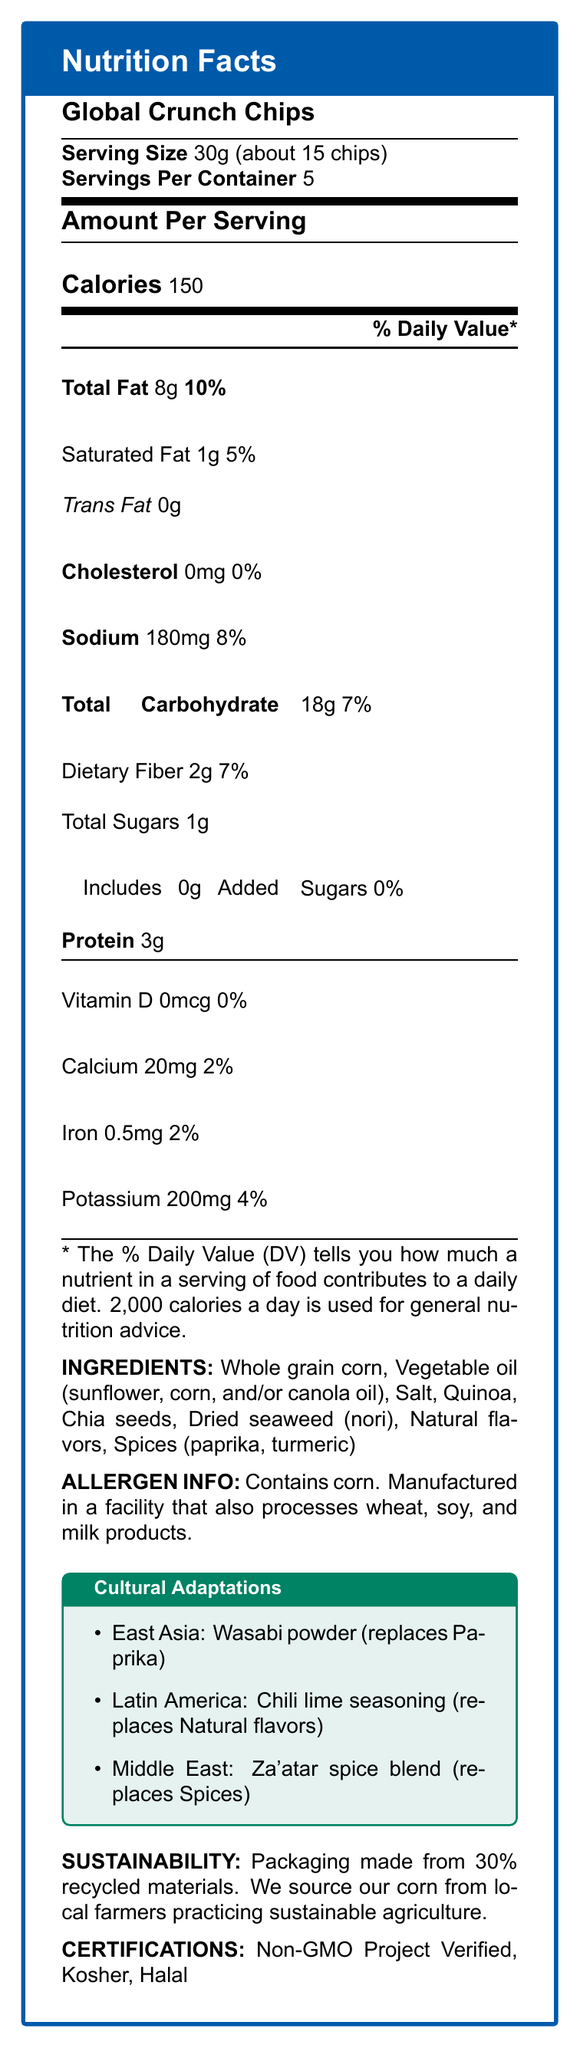what is the serving size? The serving size is directly stated as 30g, which is equivalent to about 15 chips.
Answer: 30g (about 15 chips) how many calories are in one serving? The number of calories per serving is clearly listed as 150.
Answer: 150 calories how much saturated fat is in one serving? Saturated fat content per serving is explicitly mentioned as 1g.
Answer: 1g Does the product contain any added sugars? The document states that the added sugars amount is 0g.
Answer: No what ingredient is added for the East Asian market? The East Asia adaptation uses Wasabi powder, replacing Paprika.
Answer: Wasabi powder how much protein is in one serving? The protein content in one serving is 3g.
Answer: 3g what allergens are mentioned in the document? The allergen section mentions that the product contains corn and is manufactured in a facility that processes wheat, soy, and milk products.
Answer: Corn; processed in a facility that also processes wheat, soy, and milk products how many servings are in a container? The servings per container is listed as 5.
Answer: 5 What percentage of the Daily Value of iron is provided in a single serving? The amount of iron provided in one serving is 0.5mg, which is 2% of the Daily Value.
Answer: 2% What is the sodium content per serving? The sodium content for each serving is listed as 180mg.
Answer: 180mg What is the main ingredient in the product? The first ingredient listed, implying it is the main ingredient, is whole grain corn.
Answer: Whole grain corn Which ingredient is replaced in the Middle East adaptation? A. Paprika B. Natural flavors C. Spices (paprika, turmeric) The document states that Za'atar spice blend replaces the spices (paprika, turmeric) in the Middle East adaptation.
Answer: C. Spices (paprika, turmeric) What kind of oil is used in this product? A. Olive oil B. Sunflower oil C. Coconut oil Among the oils listed, sunflower oil is one of them; olive oil and coconut oil are not mentioned.
Answer: B. Sunflower oil Is the packaging environmentally friendly? The packaging is made from 30% recycled materials and emphasizes sustainable practices.
Answer: Yes Summarize the main information presented in the document. The document outlines the nutritional content, adaptations for different regions, and sustainability efforts of the "Global Crunch Chips."
Answer: The document is a Nutrition Facts label for "Global Crunch Chips," detailing serving size, calories, and various nutrient amounts. It lists ingredients, allergens, cultural adaptations, sustainability information, and certifications. What is the daily value percentage for dietary fiber per serving? The daily value percentage for dietary fiber is listed as 7%.
Answer: 7% what kind of certifications does this product have? The document lists these three certifications for the product.
Answer: Non-GMO Project Verified, Kosher, Halal What specific regulatory compliance and guidelines are addressed in the policy considerations? The document mentions compliance with FDA and EU labeling regulations, WHO guidelines on sodium reduction, but does not specify detailed guidelines.
Answer: Not enough information 